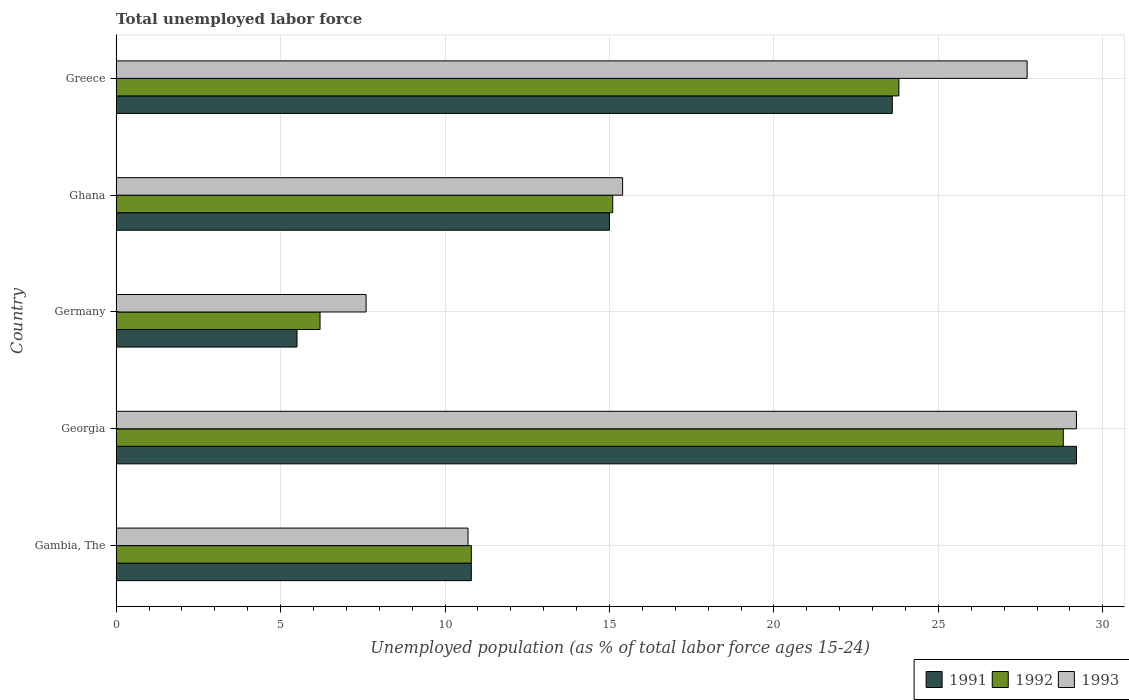How many different coloured bars are there?
Make the answer very short. 3. Are the number of bars on each tick of the Y-axis equal?
Ensure brevity in your answer.  Yes. How many bars are there on the 1st tick from the top?
Make the answer very short. 3. What is the percentage of unemployed population in in 1991 in Germany?
Give a very brief answer. 5.5. Across all countries, what is the maximum percentage of unemployed population in in 1993?
Ensure brevity in your answer.  29.2. In which country was the percentage of unemployed population in in 1991 maximum?
Provide a succinct answer. Georgia. In which country was the percentage of unemployed population in in 1993 minimum?
Make the answer very short. Germany. What is the total percentage of unemployed population in in 1991 in the graph?
Provide a short and direct response. 84.1. What is the difference between the percentage of unemployed population in in 1993 in Gambia, The and that in Greece?
Provide a succinct answer. -17. What is the difference between the percentage of unemployed population in in 1991 in Gambia, The and the percentage of unemployed population in in 1993 in Greece?
Offer a very short reply. -16.9. What is the average percentage of unemployed population in in 1992 per country?
Offer a terse response. 16.94. What is the difference between the percentage of unemployed population in in 1991 and percentage of unemployed population in in 1992 in Georgia?
Offer a terse response. 0.4. In how many countries, is the percentage of unemployed population in in 1992 greater than 19 %?
Give a very brief answer. 2. What is the ratio of the percentage of unemployed population in in 1993 in Georgia to that in Greece?
Keep it short and to the point. 1.05. Is the percentage of unemployed population in in 1992 in Germany less than that in Ghana?
Provide a succinct answer. Yes. What is the difference between the highest and the second highest percentage of unemployed population in in 1993?
Your answer should be very brief. 1.5. What is the difference between the highest and the lowest percentage of unemployed population in in 1992?
Give a very brief answer. 22.6. Is the sum of the percentage of unemployed population in in 1993 in Germany and Greece greater than the maximum percentage of unemployed population in in 1992 across all countries?
Provide a short and direct response. Yes. What does the 1st bar from the top in Ghana represents?
Provide a succinct answer. 1993. What does the 1st bar from the bottom in Germany represents?
Offer a very short reply. 1991. How many bars are there?
Offer a terse response. 15. Are all the bars in the graph horizontal?
Offer a very short reply. Yes. How many countries are there in the graph?
Your response must be concise. 5. Where does the legend appear in the graph?
Your response must be concise. Bottom right. How many legend labels are there?
Offer a terse response. 3. How are the legend labels stacked?
Your answer should be compact. Horizontal. What is the title of the graph?
Your response must be concise. Total unemployed labor force. What is the label or title of the X-axis?
Your answer should be compact. Unemployed population (as % of total labor force ages 15-24). What is the Unemployed population (as % of total labor force ages 15-24) in 1991 in Gambia, The?
Offer a very short reply. 10.8. What is the Unemployed population (as % of total labor force ages 15-24) in 1992 in Gambia, The?
Your answer should be compact. 10.8. What is the Unemployed population (as % of total labor force ages 15-24) of 1993 in Gambia, The?
Your response must be concise. 10.7. What is the Unemployed population (as % of total labor force ages 15-24) in 1991 in Georgia?
Provide a succinct answer. 29.2. What is the Unemployed population (as % of total labor force ages 15-24) in 1992 in Georgia?
Ensure brevity in your answer.  28.8. What is the Unemployed population (as % of total labor force ages 15-24) of 1993 in Georgia?
Your answer should be compact. 29.2. What is the Unemployed population (as % of total labor force ages 15-24) of 1992 in Germany?
Give a very brief answer. 6.2. What is the Unemployed population (as % of total labor force ages 15-24) of 1993 in Germany?
Your answer should be very brief. 7.6. What is the Unemployed population (as % of total labor force ages 15-24) in 1992 in Ghana?
Offer a very short reply. 15.1. What is the Unemployed population (as % of total labor force ages 15-24) in 1993 in Ghana?
Provide a short and direct response. 15.4. What is the Unemployed population (as % of total labor force ages 15-24) of 1991 in Greece?
Ensure brevity in your answer.  23.6. What is the Unemployed population (as % of total labor force ages 15-24) of 1992 in Greece?
Give a very brief answer. 23.8. What is the Unemployed population (as % of total labor force ages 15-24) of 1993 in Greece?
Offer a terse response. 27.7. Across all countries, what is the maximum Unemployed population (as % of total labor force ages 15-24) of 1991?
Keep it short and to the point. 29.2. Across all countries, what is the maximum Unemployed population (as % of total labor force ages 15-24) in 1992?
Keep it short and to the point. 28.8. Across all countries, what is the maximum Unemployed population (as % of total labor force ages 15-24) in 1993?
Make the answer very short. 29.2. Across all countries, what is the minimum Unemployed population (as % of total labor force ages 15-24) in 1991?
Make the answer very short. 5.5. Across all countries, what is the minimum Unemployed population (as % of total labor force ages 15-24) in 1992?
Offer a very short reply. 6.2. Across all countries, what is the minimum Unemployed population (as % of total labor force ages 15-24) of 1993?
Make the answer very short. 7.6. What is the total Unemployed population (as % of total labor force ages 15-24) in 1991 in the graph?
Your answer should be compact. 84.1. What is the total Unemployed population (as % of total labor force ages 15-24) in 1992 in the graph?
Keep it short and to the point. 84.7. What is the total Unemployed population (as % of total labor force ages 15-24) of 1993 in the graph?
Provide a short and direct response. 90.6. What is the difference between the Unemployed population (as % of total labor force ages 15-24) of 1991 in Gambia, The and that in Georgia?
Ensure brevity in your answer.  -18.4. What is the difference between the Unemployed population (as % of total labor force ages 15-24) in 1993 in Gambia, The and that in Georgia?
Provide a short and direct response. -18.5. What is the difference between the Unemployed population (as % of total labor force ages 15-24) of 1991 in Gambia, The and that in Germany?
Your response must be concise. 5.3. What is the difference between the Unemployed population (as % of total labor force ages 15-24) in 1993 in Gambia, The and that in Germany?
Your answer should be compact. 3.1. What is the difference between the Unemployed population (as % of total labor force ages 15-24) in 1991 in Gambia, The and that in Ghana?
Provide a short and direct response. -4.2. What is the difference between the Unemployed population (as % of total labor force ages 15-24) in 1993 in Gambia, The and that in Ghana?
Your response must be concise. -4.7. What is the difference between the Unemployed population (as % of total labor force ages 15-24) of 1991 in Gambia, The and that in Greece?
Give a very brief answer. -12.8. What is the difference between the Unemployed population (as % of total labor force ages 15-24) of 1992 in Gambia, The and that in Greece?
Keep it short and to the point. -13. What is the difference between the Unemployed population (as % of total labor force ages 15-24) of 1991 in Georgia and that in Germany?
Give a very brief answer. 23.7. What is the difference between the Unemployed population (as % of total labor force ages 15-24) in 1992 in Georgia and that in Germany?
Your answer should be very brief. 22.6. What is the difference between the Unemployed population (as % of total labor force ages 15-24) in 1993 in Georgia and that in Germany?
Provide a succinct answer. 21.6. What is the difference between the Unemployed population (as % of total labor force ages 15-24) in 1991 in Georgia and that in Ghana?
Give a very brief answer. 14.2. What is the difference between the Unemployed population (as % of total labor force ages 15-24) in 1992 in Georgia and that in Ghana?
Your response must be concise. 13.7. What is the difference between the Unemployed population (as % of total labor force ages 15-24) of 1993 in Georgia and that in Ghana?
Offer a terse response. 13.8. What is the difference between the Unemployed population (as % of total labor force ages 15-24) of 1991 in Georgia and that in Greece?
Your response must be concise. 5.6. What is the difference between the Unemployed population (as % of total labor force ages 15-24) of 1992 in Georgia and that in Greece?
Give a very brief answer. 5. What is the difference between the Unemployed population (as % of total labor force ages 15-24) of 1993 in Georgia and that in Greece?
Your response must be concise. 1.5. What is the difference between the Unemployed population (as % of total labor force ages 15-24) in 1991 in Germany and that in Ghana?
Give a very brief answer. -9.5. What is the difference between the Unemployed population (as % of total labor force ages 15-24) in 1992 in Germany and that in Ghana?
Your answer should be very brief. -8.9. What is the difference between the Unemployed population (as % of total labor force ages 15-24) of 1991 in Germany and that in Greece?
Provide a short and direct response. -18.1. What is the difference between the Unemployed population (as % of total labor force ages 15-24) in 1992 in Germany and that in Greece?
Provide a short and direct response. -17.6. What is the difference between the Unemployed population (as % of total labor force ages 15-24) of 1993 in Germany and that in Greece?
Offer a terse response. -20.1. What is the difference between the Unemployed population (as % of total labor force ages 15-24) in 1993 in Ghana and that in Greece?
Provide a succinct answer. -12.3. What is the difference between the Unemployed population (as % of total labor force ages 15-24) in 1991 in Gambia, The and the Unemployed population (as % of total labor force ages 15-24) in 1993 in Georgia?
Your answer should be compact. -18.4. What is the difference between the Unemployed population (as % of total labor force ages 15-24) in 1992 in Gambia, The and the Unemployed population (as % of total labor force ages 15-24) in 1993 in Georgia?
Make the answer very short. -18.4. What is the difference between the Unemployed population (as % of total labor force ages 15-24) in 1991 in Gambia, The and the Unemployed population (as % of total labor force ages 15-24) in 1992 in Germany?
Provide a short and direct response. 4.6. What is the difference between the Unemployed population (as % of total labor force ages 15-24) of 1991 in Gambia, The and the Unemployed population (as % of total labor force ages 15-24) of 1993 in Germany?
Offer a very short reply. 3.2. What is the difference between the Unemployed population (as % of total labor force ages 15-24) of 1992 in Gambia, The and the Unemployed population (as % of total labor force ages 15-24) of 1993 in Germany?
Provide a succinct answer. 3.2. What is the difference between the Unemployed population (as % of total labor force ages 15-24) in 1991 in Gambia, The and the Unemployed population (as % of total labor force ages 15-24) in 1992 in Ghana?
Your answer should be very brief. -4.3. What is the difference between the Unemployed population (as % of total labor force ages 15-24) in 1992 in Gambia, The and the Unemployed population (as % of total labor force ages 15-24) in 1993 in Ghana?
Provide a short and direct response. -4.6. What is the difference between the Unemployed population (as % of total labor force ages 15-24) in 1991 in Gambia, The and the Unemployed population (as % of total labor force ages 15-24) in 1992 in Greece?
Offer a very short reply. -13. What is the difference between the Unemployed population (as % of total labor force ages 15-24) in 1991 in Gambia, The and the Unemployed population (as % of total labor force ages 15-24) in 1993 in Greece?
Ensure brevity in your answer.  -16.9. What is the difference between the Unemployed population (as % of total labor force ages 15-24) in 1992 in Gambia, The and the Unemployed population (as % of total labor force ages 15-24) in 1993 in Greece?
Offer a terse response. -16.9. What is the difference between the Unemployed population (as % of total labor force ages 15-24) of 1991 in Georgia and the Unemployed population (as % of total labor force ages 15-24) of 1993 in Germany?
Provide a succinct answer. 21.6. What is the difference between the Unemployed population (as % of total labor force ages 15-24) of 1992 in Georgia and the Unemployed population (as % of total labor force ages 15-24) of 1993 in Germany?
Provide a short and direct response. 21.2. What is the difference between the Unemployed population (as % of total labor force ages 15-24) in 1991 in Germany and the Unemployed population (as % of total labor force ages 15-24) in 1993 in Ghana?
Offer a very short reply. -9.9. What is the difference between the Unemployed population (as % of total labor force ages 15-24) in 1992 in Germany and the Unemployed population (as % of total labor force ages 15-24) in 1993 in Ghana?
Provide a short and direct response. -9.2. What is the difference between the Unemployed population (as % of total labor force ages 15-24) in 1991 in Germany and the Unemployed population (as % of total labor force ages 15-24) in 1992 in Greece?
Offer a terse response. -18.3. What is the difference between the Unemployed population (as % of total labor force ages 15-24) of 1991 in Germany and the Unemployed population (as % of total labor force ages 15-24) of 1993 in Greece?
Offer a terse response. -22.2. What is the difference between the Unemployed population (as % of total labor force ages 15-24) in 1992 in Germany and the Unemployed population (as % of total labor force ages 15-24) in 1993 in Greece?
Provide a succinct answer. -21.5. What is the average Unemployed population (as % of total labor force ages 15-24) in 1991 per country?
Offer a very short reply. 16.82. What is the average Unemployed population (as % of total labor force ages 15-24) in 1992 per country?
Provide a succinct answer. 16.94. What is the average Unemployed population (as % of total labor force ages 15-24) of 1993 per country?
Offer a very short reply. 18.12. What is the difference between the Unemployed population (as % of total labor force ages 15-24) in 1991 and Unemployed population (as % of total labor force ages 15-24) in 1992 in Gambia, The?
Offer a terse response. 0. What is the difference between the Unemployed population (as % of total labor force ages 15-24) in 1991 and Unemployed population (as % of total labor force ages 15-24) in 1993 in Gambia, The?
Keep it short and to the point. 0.1. What is the difference between the Unemployed population (as % of total labor force ages 15-24) in 1992 and Unemployed population (as % of total labor force ages 15-24) in 1993 in Georgia?
Your answer should be compact. -0.4. What is the difference between the Unemployed population (as % of total labor force ages 15-24) of 1991 and Unemployed population (as % of total labor force ages 15-24) of 1992 in Germany?
Give a very brief answer. -0.7. What is the difference between the Unemployed population (as % of total labor force ages 15-24) of 1992 and Unemployed population (as % of total labor force ages 15-24) of 1993 in Germany?
Ensure brevity in your answer.  -1.4. What is the difference between the Unemployed population (as % of total labor force ages 15-24) in 1991 and Unemployed population (as % of total labor force ages 15-24) in 1993 in Greece?
Give a very brief answer. -4.1. What is the difference between the Unemployed population (as % of total labor force ages 15-24) of 1992 and Unemployed population (as % of total labor force ages 15-24) of 1993 in Greece?
Your answer should be very brief. -3.9. What is the ratio of the Unemployed population (as % of total labor force ages 15-24) in 1991 in Gambia, The to that in Georgia?
Your response must be concise. 0.37. What is the ratio of the Unemployed population (as % of total labor force ages 15-24) of 1993 in Gambia, The to that in Georgia?
Provide a short and direct response. 0.37. What is the ratio of the Unemployed population (as % of total labor force ages 15-24) of 1991 in Gambia, The to that in Germany?
Provide a short and direct response. 1.96. What is the ratio of the Unemployed population (as % of total labor force ages 15-24) in 1992 in Gambia, The to that in Germany?
Offer a very short reply. 1.74. What is the ratio of the Unemployed population (as % of total labor force ages 15-24) of 1993 in Gambia, The to that in Germany?
Provide a short and direct response. 1.41. What is the ratio of the Unemployed population (as % of total labor force ages 15-24) of 1991 in Gambia, The to that in Ghana?
Your response must be concise. 0.72. What is the ratio of the Unemployed population (as % of total labor force ages 15-24) of 1992 in Gambia, The to that in Ghana?
Your response must be concise. 0.72. What is the ratio of the Unemployed population (as % of total labor force ages 15-24) of 1993 in Gambia, The to that in Ghana?
Offer a very short reply. 0.69. What is the ratio of the Unemployed population (as % of total labor force ages 15-24) in 1991 in Gambia, The to that in Greece?
Your answer should be very brief. 0.46. What is the ratio of the Unemployed population (as % of total labor force ages 15-24) of 1992 in Gambia, The to that in Greece?
Make the answer very short. 0.45. What is the ratio of the Unemployed population (as % of total labor force ages 15-24) in 1993 in Gambia, The to that in Greece?
Your response must be concise. 0.39. What is the ratio of the Unemployed population (as % of total labor force ages 15-24) in 1991 in Georgia to that in Germany?
Provide a short and direct response. 5.31. What is the ratio of the Unemployed population (as % of total labor force ages 15-24) in 1992 in Georgia to that in Germany?
Keep it short and to the point. 4.65. What is the ratio of the Unemployed population (as % of total labor force ages 15-24) of 1993 in Georgia to that in Germany?
Make the answer very short. 3.84. What is the ratio of the Unemployed population (as % of total labor force ages 15-24) in 1991 in Georgia to that in Ghana?
Provide a succinct answer. 1.95. What is the ratio of the Unemployed population (as % of total labor force ages 15-24) of 1992 in Georgia to that in Ghana?
Provide a succinct answer. 1.91. What is the ratio of the Unemployed population (as % of total labor force ages 15-24) of 1993 in Georgia to that in Ghana?
Make the answer very short. 1.9. What is the ratio of the Unemployed population (as % of total labor force ages 15-24) of 1991 in Georgia to that in Greece?
Your response must be concise. 1.24. What is the ratio of the Unemployed population (as % of total labor force ages 15-24) of 1992 in Georgia to that in Greece?
Ensure brevity in your answer.  1.21. What is the ratio of the Unemployed population (as % of total labor force ages 15-24) in 1993 in Georgia to that in Greece?
Offer a very short reply. 1.05. What is the ratio of the Unemployed population (as % of total labor force ages 15-24) in 1991 in Germany to that in Ghana?
Offer a very short reply. 0.37. What is the ratio of the Unemployed population (as % of total labor force ages 15-24) in 1992 in Germany to that in Ghana?
Your response must be concise. 0.41. What is the ratio of the Unemployed population (as % of total labor force ages 15-24) in 1993 in Germany to that in Ghana?
Offer a terse response. 0.49. What is the ratio of the Unemployed population (as % of total labor force ages 15-24) in 1991 in Germany to that in Greece?
Provide a short and direct response. 0.23. What is the ratio of the Unemployed population (as % of total labor force ages 15-24) in 1992 in Germany to that in Greece?
Give a very brief answer. 0.26. What is the ratio of the Unemployed population (as % of total labor force ages 15-24) of 1993 in Germany to that in Greece?
Your response must be concise. 0.27. What is the ratio of the Unemployed population (as % of total labor force ages 15-24) of 1991 in Ghana to that in Greece?
Your response must be concise. 0.64. What is the ratio of the Unemployed population (as % of total labor force ages 15-24) in 1992 in Ghana to that in Greece?
Provide a succinct answer. 0.63. What is the ratio of the Unemployed population (as % of total labor force ages 15-24) of 1993 in Ghana to that in Greece?
Offer a terse response. 0.56. What is the difference between the highest and the lowest Unemployed population (as % of total labor force ages 15-24) in 1991?
Your response must be concise. 23.7. What is the difference between the highest and the lowest Unemployed population (as % of total labor force ages 15-24) in 1992?
Keep it short and to the point. 22.6. What is the difference between the highest and the lowest Unemployed population (as % of total labor force ages 15-24) of 1993?
Ensure brevity in your answer.  21.6. 